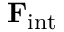Convert formula to latex. <formula><loc_0><loc_0><loc_500><loc_500>F _ { i n t }</formula> 